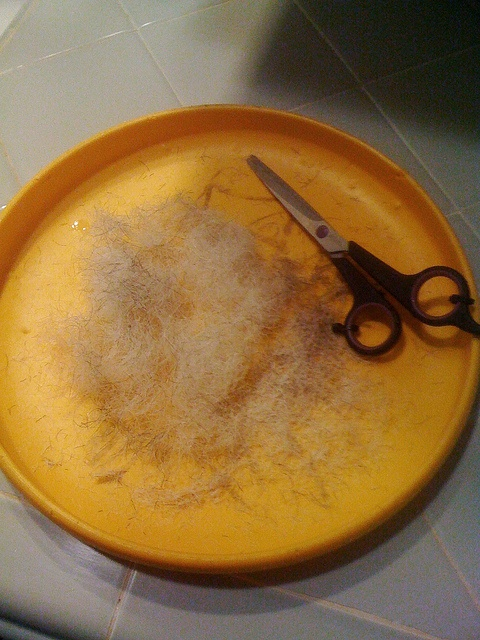Describe the objects in this image and their specific colors. I can see frisbee in darkgray, olive, orange, and tan tones and scissors in darkgray, black, maroon, and brown tones in this image. 